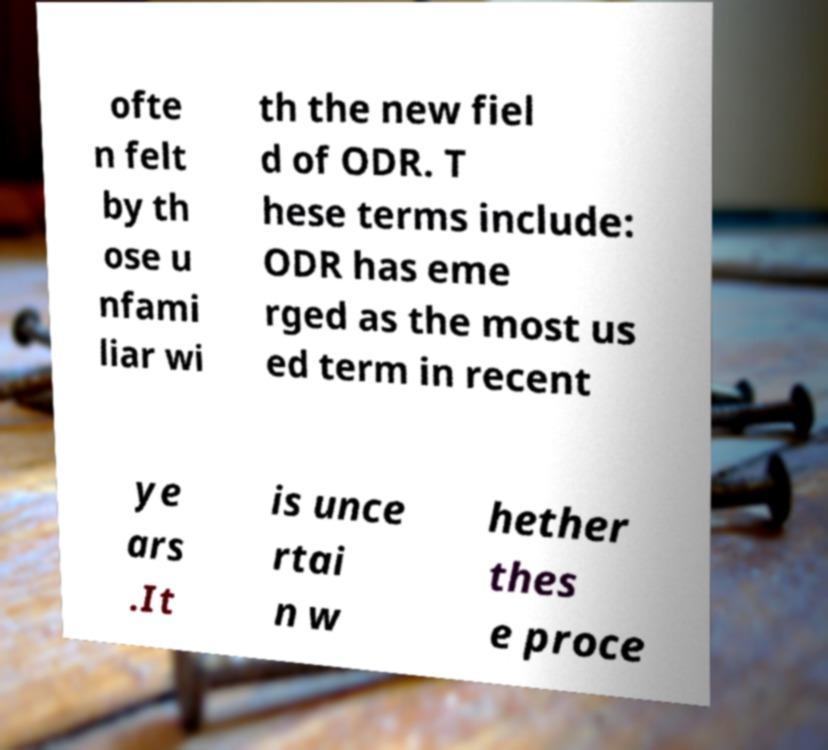Please identify and transcribe the text found in this image. ofte n felt by th ose u nfami liar wi th the new fiel d of ODR. T hese terms include: ODR has eme rged as the most us ed term in recent ye ars .It is unce rtai n w hether thes e proce 